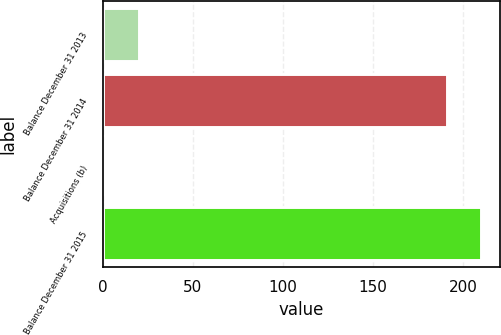<chart> <loc_0><loc_0><loc_500><loc_500><bar_chart><fcel>Balance December 31 2013<fcel>Balance December 31 2014<fcel>Acquisitions (b)<fcel>Balance December 31 2015<nl><fcel>20.1<fcel>191<fcel>1<fcel>210.1<nl></chart> 